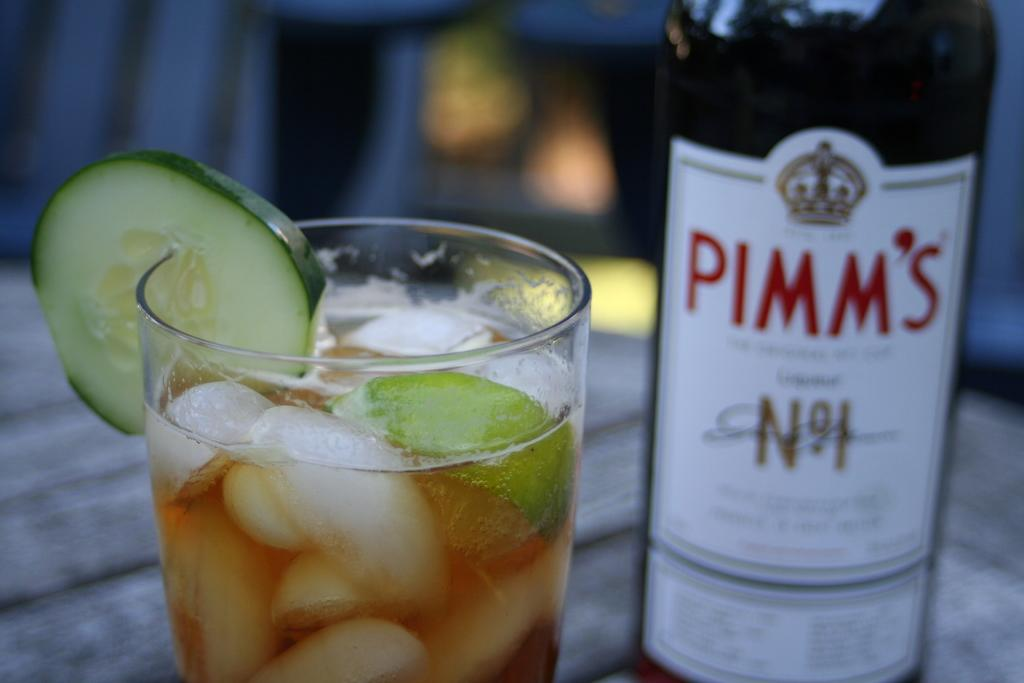<image>
Render a clear and concise summary of the photo. a pimm's bottle next to a drink with iuce 